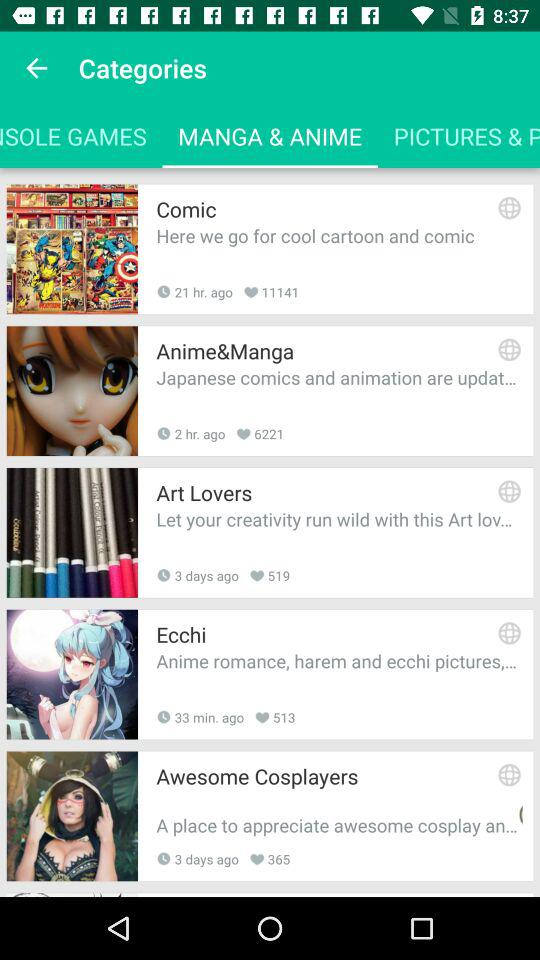How many people like "Comic"? There are 11141 people who like "Comic". 